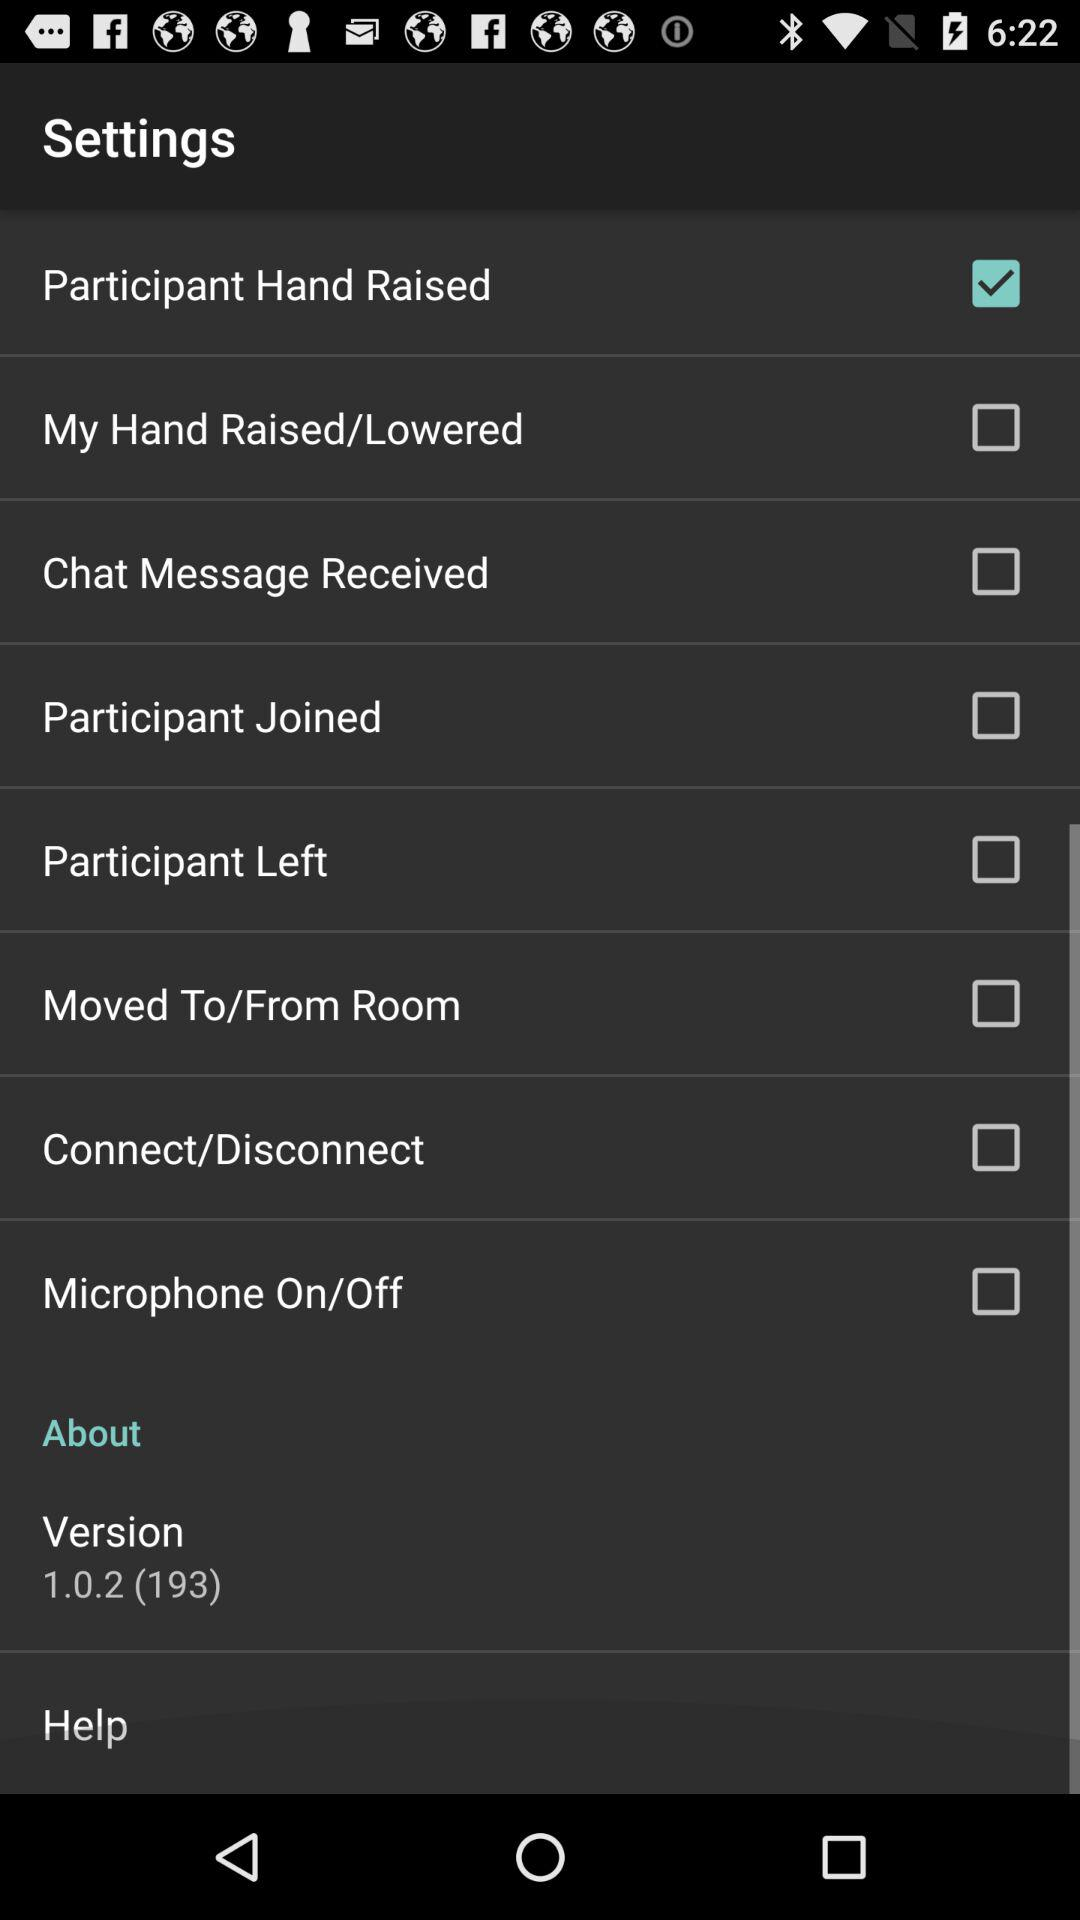What is the status of "Participant Hand Raised"? The status of "Participant Hand Raised" is "on". 